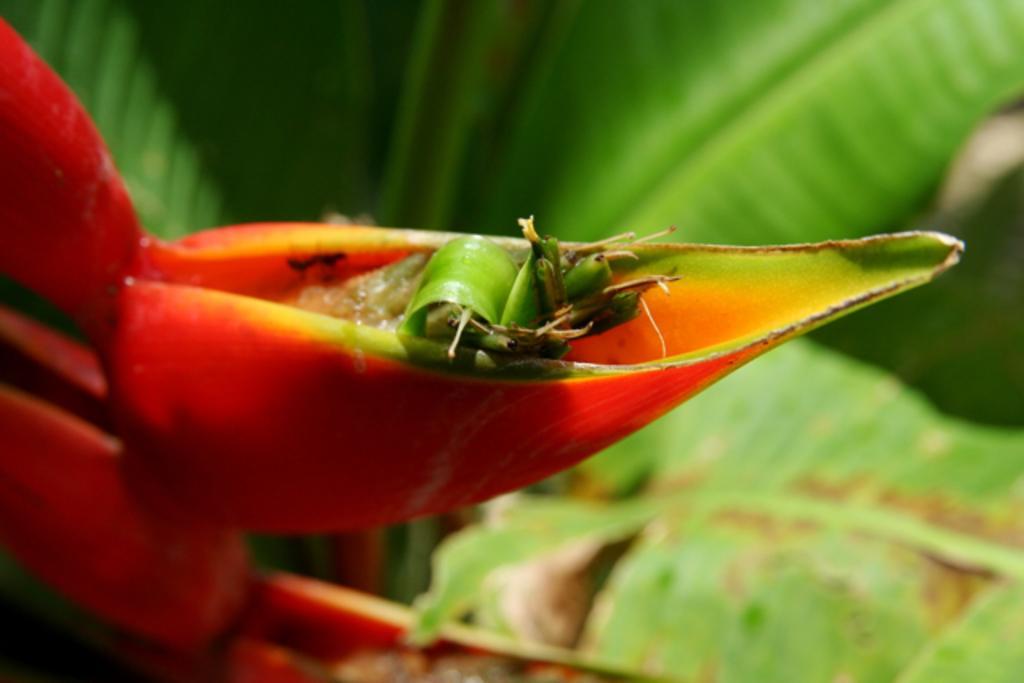Could you give a brief overview of what you see in this image? On the left side it is a bud in orange color. These are the green leaves in the middle of an image. 